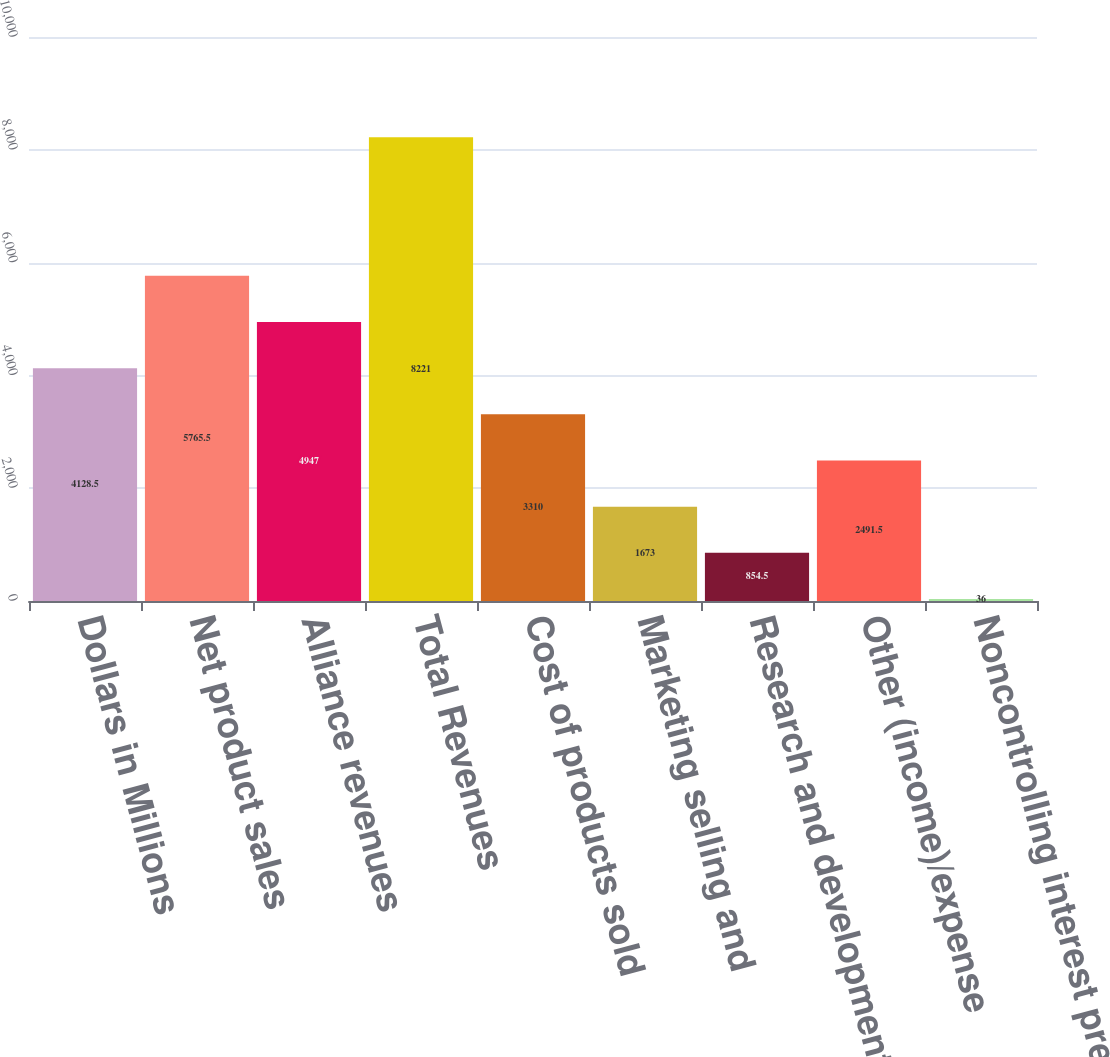<chart> <loc_0><loc_0><loc_500><loc_500><bar_chart><fcel>Dollars in Millions<fcel>Net product sales<fcel>Alliance revenues<fcel>Total Revenues<fcel>Cost of products sold<fcel>Marketing selling and<fcel>Research and development<fcel>Other (income)/expense<fcel>Noncontrolling interest pretax<nl><fcel>4128.5<fcel>5765.5<fcel>4947<fcel>8221<fcel>3310<fcel>1673<fcel>854.5<fcel>2491.5<fcel>36<nl></chart> 